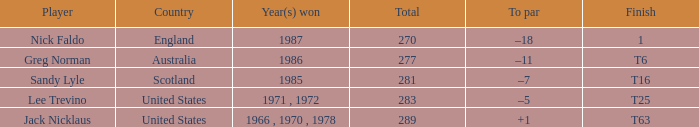Where does sandy lyle, the player, come from if his total is more than 270? Scotland. 